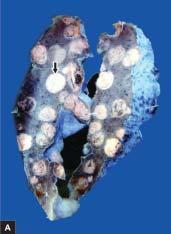what does sectioned surface of the lung show?
Answer the question using a single word or phrase. Replacement of slaty-grey spongy parenchyma 